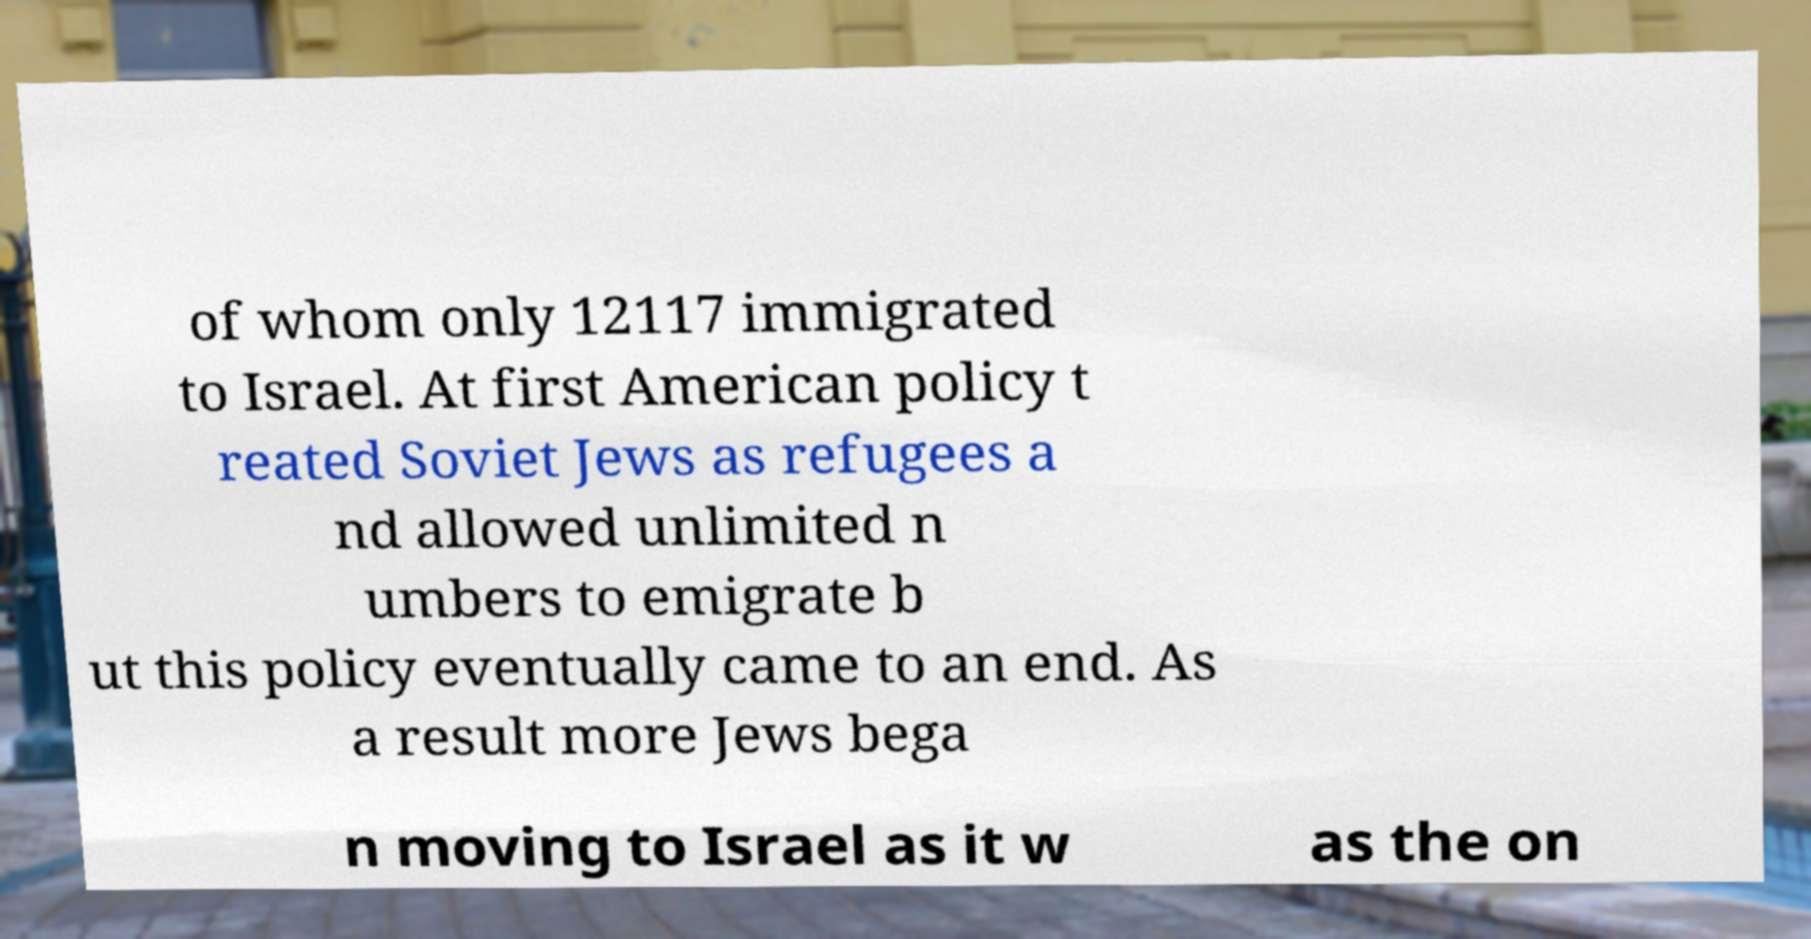What messages or text are displayed in this image? I need them in a readable, typed format. of whom only 12117 immigrated to Israel. At first American policy t reated Soviet Jews as refugees a nd allowed unlimited n umbers to emigrate b ut this policy eventually came to an end. As a result more Jews bega n moving to Israel as it w as the on 